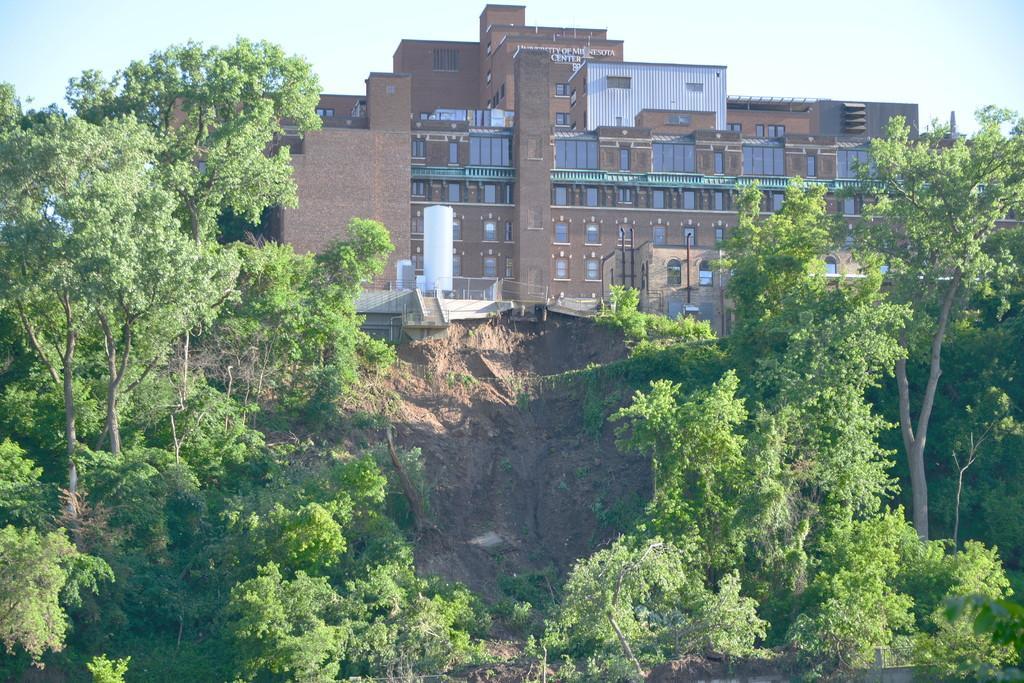How would you summarize this image in a sentence or two? In this image, we can see buildings, trees and poles and some tanks. At the top, there is sky. 